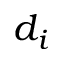<formula> <loc_0><loc_0><loc_500><loc_500>d _ { i }</formula> 